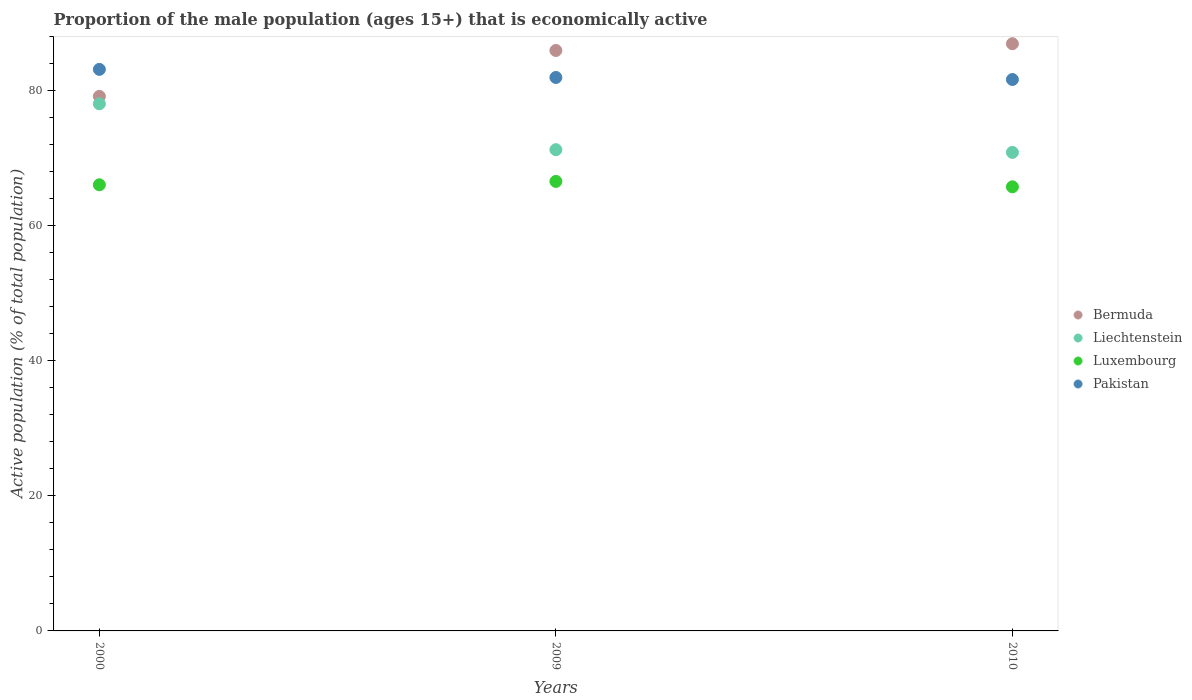How many different coloured dotlines are there?
Your answer should be compact. 4. Is the number of dotlines equal to the number of legend labels?
Your response must be concise. Yes. What is the proportion of the male population that is economically active in Luxembourg in 2009?
Offer a terse response. 66.6. Across all years, what is the maximum proportion of the male population that is economically active in Liechtenstein?
Make the answer very short. 78.1. Across all years, what is the minimum proportion of the male population that is economically active in Liechtenstein?
Your answer should be very brief. 70.9. In which year was the proportion of the male population that is economically active in Bermuda maximum?
Your response must be concise. 2010. What is the total proportion of the male population that is economically active in Luxembourg in the graph?
Provide a succinct answer. 198.5. What is the difference between the proportion of the male population that is economically active in Liechtenstein in 2009 and that in 2010?
Offer a terse response. 0.4. What is the difference between the proportion of the male population that is economically active in Liechtenstein in 2000 and the proportion of the male population that is economically active in Bermuda in 2010?
Your answer should be compact. -8.9. What is the average proportion of the male population that is economically active in Bermuda per year?
Give a very brief answer. 84.07. In the year 2000, what is the difference between the proportion of the male population that is economically active in Bermuda and proportion of the male population that is economically active in Liechtenstein?
Make the answer very short. 1.1. In how many years, is the proportion of the male population that is economically active in Liechtenstein greater than 44 %?
Your response must be concise. 3. What is the ratio of the proportion of the male population that is economically active in Bermuda in 2009 to that in 2010?
Your answer should be compact. 0.99. What is the difference between the highest and the second highest proportion of the male population that is economically active in Bermuda?
Offer a very short reply. 1. What is the difference between the highest and the lowest proportion of the male population that is economically active in Bermuda?
Ensure brevity in your answer.  7.8. Is the sum of the proportion of the male population that is economically active in Pakistan in 2009 and 2010 greater than the maximum proportion of the male population that is economically active in Bermuda across all years?
Your answer should be compact. Yes. Is it the case that in every year, the sum of the proportion of the male population that is economically active in Luxembourg and proportion of the male population that is economically active in Pakistan  is greater than the sum of proportion of the male population that is economically active in Liechtenstein and proportion of the male population that is economically active in Bermuda?
Offer a very short reply. No. Is the proportion of the male population that is economically active in Liechtenstein strictly greater than the proportion of the male population that is economically active in Pakistan over the years?
Offer a very short reply. No. Is the proportion of the male population that is economically active in Liechtenstein strictly less than the proportion of the male population that is economically active in Pakistan over the years?
Provide a short and direct response. Yes. How many dotlines are there?
Keep it short and to the point. 4. What is the difference between two consecutive major ticks on the Y-axis?
Your answer should be very brief. 20. Does the graph contain grids?
Make the answer very short. No. How many legend labels are there?
Provide a succinct answer. 4. What is the title of the graph?
Your answer should be compact. Proportion of the male population (ages 15+) that is economically active. What is the label or title of the Y-axis?
Make the answer very short. Active population (% of total population). What is the Active population (% of total population) of Bermuda in 2000?
Your answer should be very brief. 79.2. What is the Active population (% of total population) of Liechtenstein in 2000?
Offer a very short reply. 78.1. What is the Active population (% of total population) of Luxembourg in 2000?
Provide a short and direct response. 66.1. What is the Active population (% of total population) of Pakistan in 2000?
Ensure brevity in your answer.  83.2. What is the Active population (% of total population) in Liechtenstein in 2009?
Provide a succinct answer. 71.3. What is the Active population (% of total population) in Luxembourg in 2009?
Your answer should be compact. 66.6. What is the Active population (% of total population) of Pakistan in 2009?
Offer a terse response. 82. What is the Active population (% of total population) in Bermuda in 2010?
Keep it short and to the point. 87. What is the Active population (% of total population) in Liechtenstein in 2010?
Give a very brief answer. 70.9. What is the Active population (% of total population) in Luxembourg in 2010?
Make the answer very short. 65.8. What is the Active population (% of total population) in Pakistan in 2010?
Provide a succinct answer. 81.7. Across all years, what is the maximum Active population (% of total population) in Liechtenstein?
Make the answer very short. 78.1. Across all years, what is the maximum Active population (% of total population) of Luxembourg?
Your response must be concise. 66.6. Across all years, what is the maximum Active population (% of total population) in Pakistan?
Your answer should be very brief. 83.2. Across all years, what is the minimum Active population (% of total population) in Bermuda?
Your answer should be compact. 79.2. Across all years, what is the minimum Active population (% of total population) in Liechtenstein?
Make the answer very short. 70.9. Across all years, what is the minimum Active population (% of total population) of Luxembourg?
Your answer should be compact. 65.8. Across all years, what is the minimum Active population (% of total population) of Pakistan?
Keep it short and to the point. 81.7. What is the total Active population (% of total population) of Bermuda in the graph?
Your answer should be compact. 252.2. What is the total Active population (% of total population) of Liechtenstein in the graph?
Give a very brief answer. 220.3. What is the total Active population (% of total population) of Luxembourg in the graph?
Give a very brief answer. 198.5. What is the total Active population (% of total population) in Pakistan in the graph?
Keep it short and to the point. 246.9. What is the difference between the Active population (% of total population) of Bermuda in 2000 and that in 2009?
Your answer should be compact. -6.8. What is the difference between the Active population (% of total population) of Liechtenstein in 2000 and that in 2009?
Provide a short and direct response. 6.8. What is the difference between the Active population (% of total population) of Pakistan in 2000 and that in 2009?
Your response must be concise. 1.2. What is the difference between the Active population (% of total population) of Bermuda in 2000 and that in 2010?
Give a very brief answer. -7.8. What is the difference between the Active population (% of total population) in Liechtenstein in 2000 and that in 2010?
Ensure brevity in your answer.  7.2. What is the difference between the Active population (% of total population) of Luxembourg in 2000 and that in 2010?
Make the answer very short. 0.3. What is the difference between the Active population (% of total population) of Bermuda in 2009 and that in 2010?
Your response must be concise. -1. What is the difference between the Active population (% of total population) of Liechtenstein in 2009 and that in 2010?
Provide a succinct answer. 0.4. What is the difference between the Active population (% of total population) of Bermuda in 2000 and the Active population (% of total population) of Liechtenstein in 2009?
Your answer should be compact. 7.9. What is the difference between the Active population (% of total population) of Liechtenstein in 2000 and the Active population (% of total population) of Luxembourg in 2009?
Offer a very short reply. 11.5. What is the difference between the Active population (% of total population) of Luxembourg in 2000 and the Active population (% of total population) of Pakistan in 2009?
Ensure brevity in your answer.  -15.9. What is the difference between the Active population (% of total population) in Bermuda in 2000 and the Active population (% of total population) in Luxembourg in 2010?
Offer a terse response. 13.4. What is the difference between the Active population (% of total population) in Bermuda in 2000 and the Active population (% of total population) in Pakistan in 2010?
Provide a short and direct response. -2.5. What is the difference between the Active population (% of total population) of Liechtenstein in 2000 and the Active population (% of total population) of Luxembourg in 2010?
Provide a succinct answer. 12.3. What is the difference between the Active population (% of total population) in Liechtenstein in 2000 and the Active population (% of total population) in Pakistan in 2010?
Your response must be concise. -3.6. What is the difference between the Active population (% of total population) in Luxembourg in 2000 and the Active population (% of total population) in Pakistan in 2010?
Keep it short and to the point. -15.6. What is the difference between the Active population (% of total population) in Bermuda in 2009 and the Active population (% of total population) in Luxembourg in 2010?
Make the answer very short. 20.2. What is the difference between the Active population (% of total population) of Bermuda in 2009 and the Active population (% of total population) of Pakistan in 2010?
Keep it short and to the point. 4.3. What is the difference between the Active population (% of total population) of Liechtenstein in 2009 and the Active population (% of total population) of Luxembourg in 2010?
Provide a short and direct response. 5.5. What is the difference between the Active population (% of total population) of Liechtenstein in 2009 and the Active population (% of total population) of Pakistan in 2010?
Give a very brief answer. -10.4. What is the difference between the Active population (% of total population) of Luxembourg in 2009 and the Active population (% of total population) of Pakistan in 2010?
Your answer should be very brief. -15.1. What is the average Active population (% of total population) of Bermuda per year?
Provide a succinct answer. 84.07. What is the average Active population (% of total population) of Liechtenstein per year?
Give a very brief answer. 73.43. What is the average Active population (% of total population) of Luxembourg per year?
Give a very brief answer. 66.17. What is the average Active population (% of total population) of Pakistan per year?
Provide a short and direct response. 82.3. In the year 2000, what is the difference between the Active population (% of total population) in Bermuda and Active population (% of total population) in Pakistan?
Keep it short and to the point. -4. In the year 2000, what is the difference between the Active population (% of total population) of Liechtenstein and Active population (% of total population) of Luxembourg?
Your answer should be very brief. 12. In the year 2000, what is the difference between the Active population (% of total population) of Liechtenstein and Active population (% of total population) of Pakistan?
Keep it short and to the point. -5.1. In the year 2000, what is the difference between the Active population (% of total population) in Luxembourg and Active population (% of total population) in Pakistan?
Provide a short and direct response. -17.1. In the year 2009, what is the difference between the Active population (% of total population) in Bermuda and Active population (% of total population) in Liechtenstein?
Provide a short and direct response. 14.7. In the year 2009, what is the difference between the Active population (% of total population) of Bermuda and Active population (% of total population) of Luxembourg?
Ensure brevity in your answer.  19.4. In the year 2009, what is the difference between the Active population (% of total population) in Luxembourg and Active population (% of total population) in Pakistan?
Provide a short and direct response. -15.4. In the year 2010, what is the difference between the Active population (% of total population) of Bermuda and Active population (% of total population) of Liechtenstein?
Make the answer very short. 16.1. In the year 2010, what is the difference between the Active population (% of total population) of Bermuda and Active population (% of total population) of Luxembourg?
Give a very brief answer. 21.2. In the year 2010, what is the difference between the Active population (% of total population) in Luxembourg and Active population (% of total population) in Pakistan?
Provide a succinct answer. -15.9. What is the ratio of the Active population (% of total population) in Bermuda in 2000 to that in 2009?
Your answer should be very brief. 0.92. What is the ratio of the Active population (% of total population) of Liechtenstein in 2000 to that in 2009?
Provide a succinct answer. 1.1. What is the ratio of the Active population (% of total population) in Pakistan in 2000 to that in 2009?
Make the answer very short. 1.01. What is the ratio of the Active population (% of total population) of Bermuda in 2000 to that in 2010?
Your response must be concise. 0.91. What is the ratio of the Active population (% of total population) in Liechtenstein in 2000 to that in 2010?
Provide a short and direct response. 1.1. What is the ratio of the Active population (% of total population) in Pakistan in 2000 to that in 2010?
Provide a short and direct response. 1.02. What is the ratio of the Active population (% of total population) in Liechtenstein in 2009 to that in 2010?
Offer a very short reply. 1.01. What is the ratio of the Active population (% of total population) of Luxembourg in 2009 to that in 2010?
Your answer should be very brief. 1.01. What is the ratio of the Active population (% of total population) in Pakistan in 2009 to that in 2010?
Give a very brief answer. 1. What is the difference between the highest and the second highest Active population (% of total population) in Bermuda?
Offer a terse response. 1. What is the difference between the highest and the second highest Active population (% of total population) of Luxembourg?
Provide a short and direct response. 0.5. What is the difference between the highest and the second highest Active population (% of total population) of Pakistan?
Offer a very short reply. 1.2. What is the difference between the highest and the lowest Active population (% of total population) of Luxembourg?
Provide a succinct answer. 0.8. 